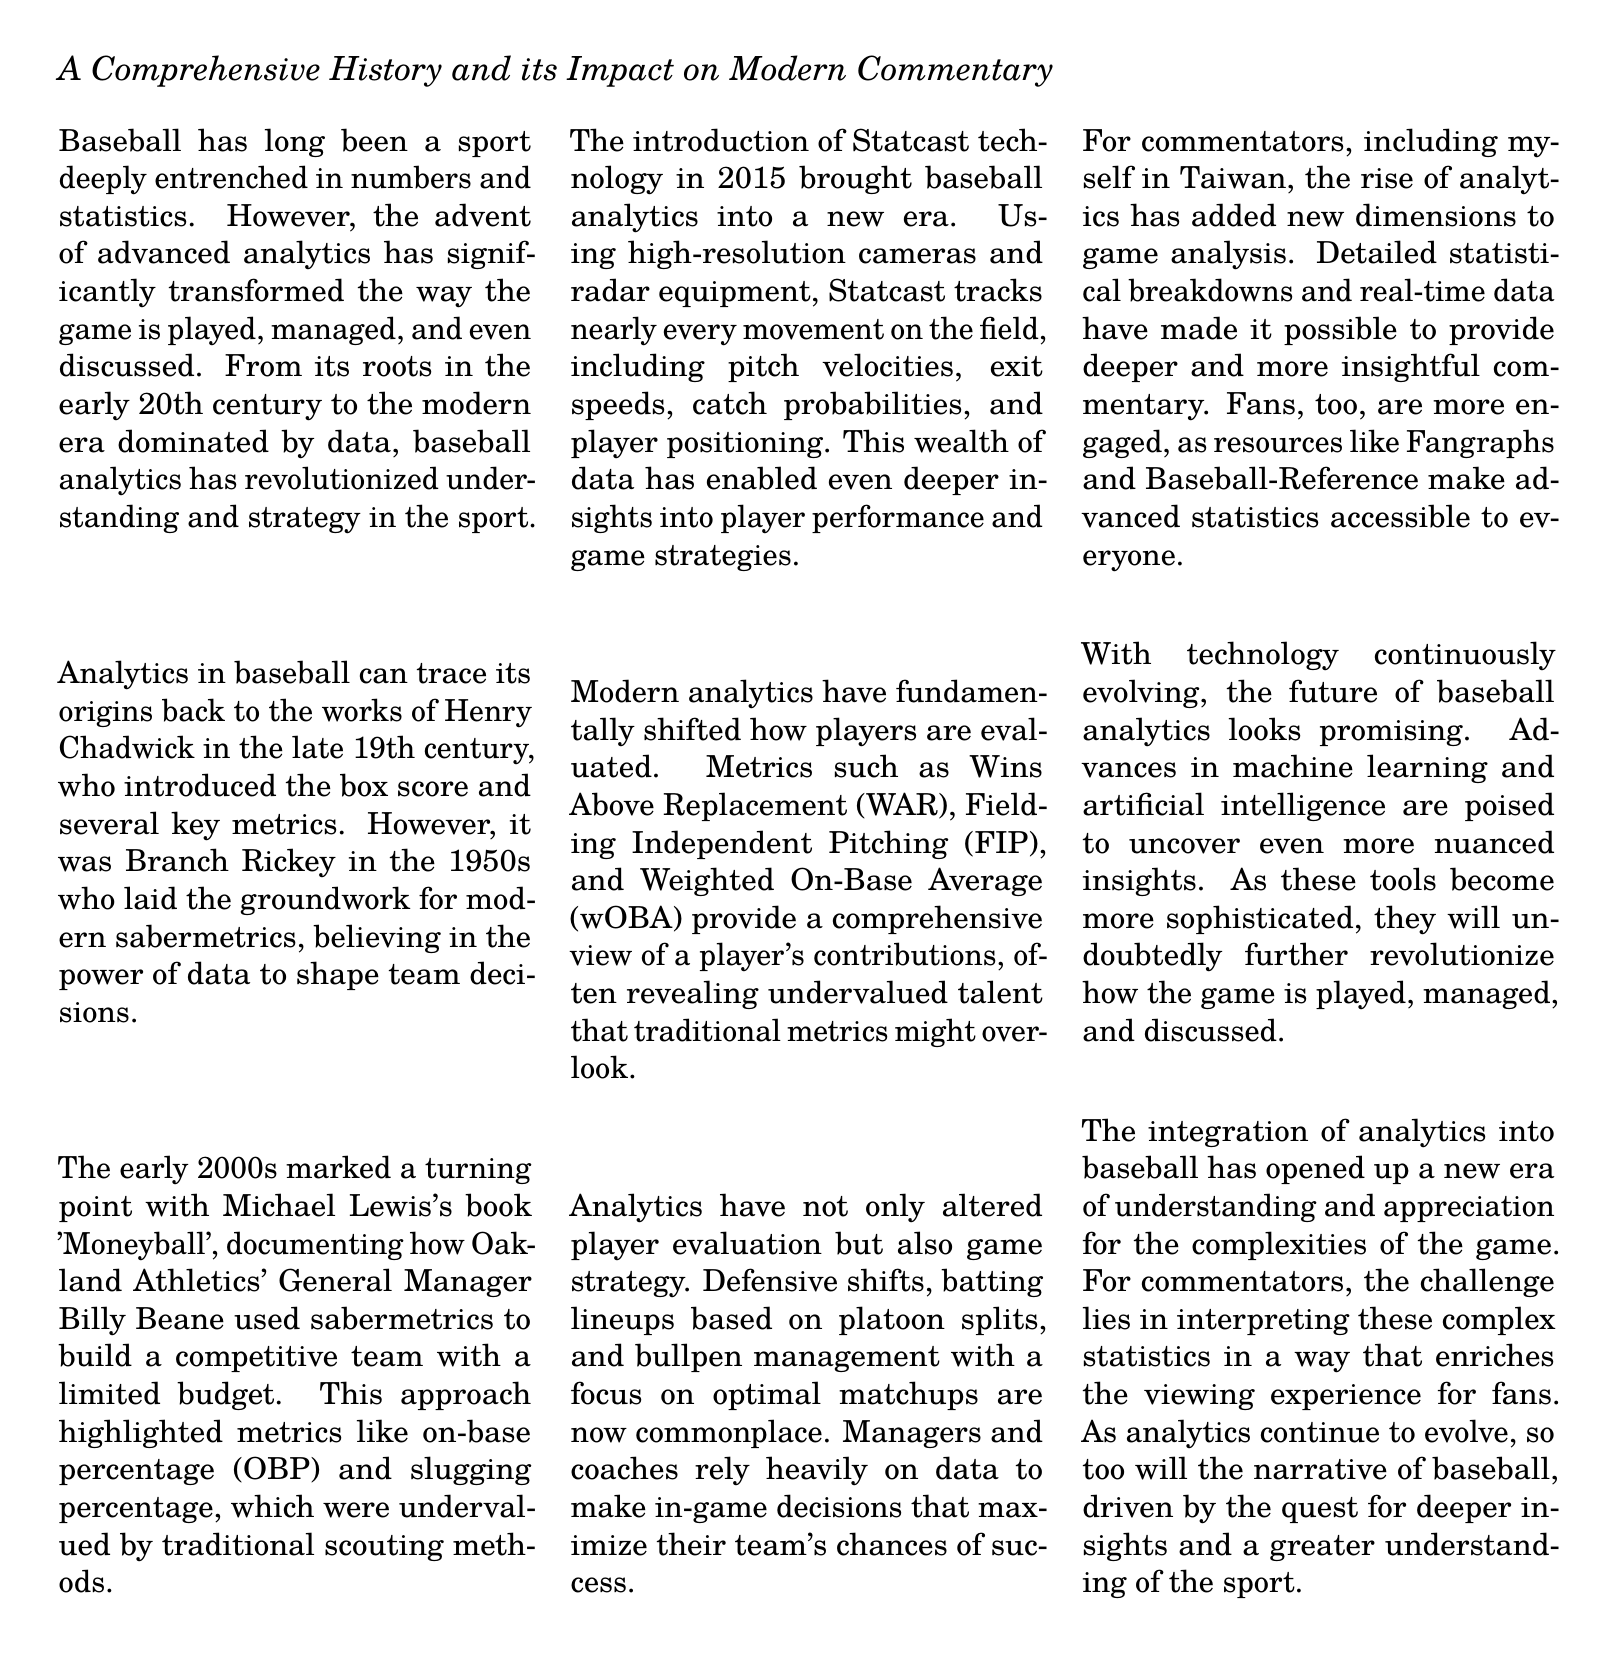What is the title of the document? The title is clearly stated at the beginning of the document.
Answer: The Evolution of Baseball Analytics Who is considered a pioneer in baseball analytics? The document identifies an early figure in baseball analytics.
Answer: Henry Chadwick What technology was introduced in 2015? This refers to a significant technological advancement in baseball analytics mentioned in the document.
Answer: Statcast What key metric was highlighted in the Moneyball era? This metric played a crucial role in the approach documented in 'Moneyball.'
Answer: On-base percentage What does WAR stand for? The document mentions a specific player evaluation metric.
Answer: Wins Above Replacement What is a major impact of analytics on game strategy? The document discusses various changes in game strategy due to analytics.
Answer: Defensive shifts What role do advanced statistics play in commentary? The document explains how analytics have influenced the field of commentary.
Answer: Deeper insights What is one tool expected to impact the future of analytics? The document mentions a technological advance that will shape the future.
Answer: Artificial intelligence 